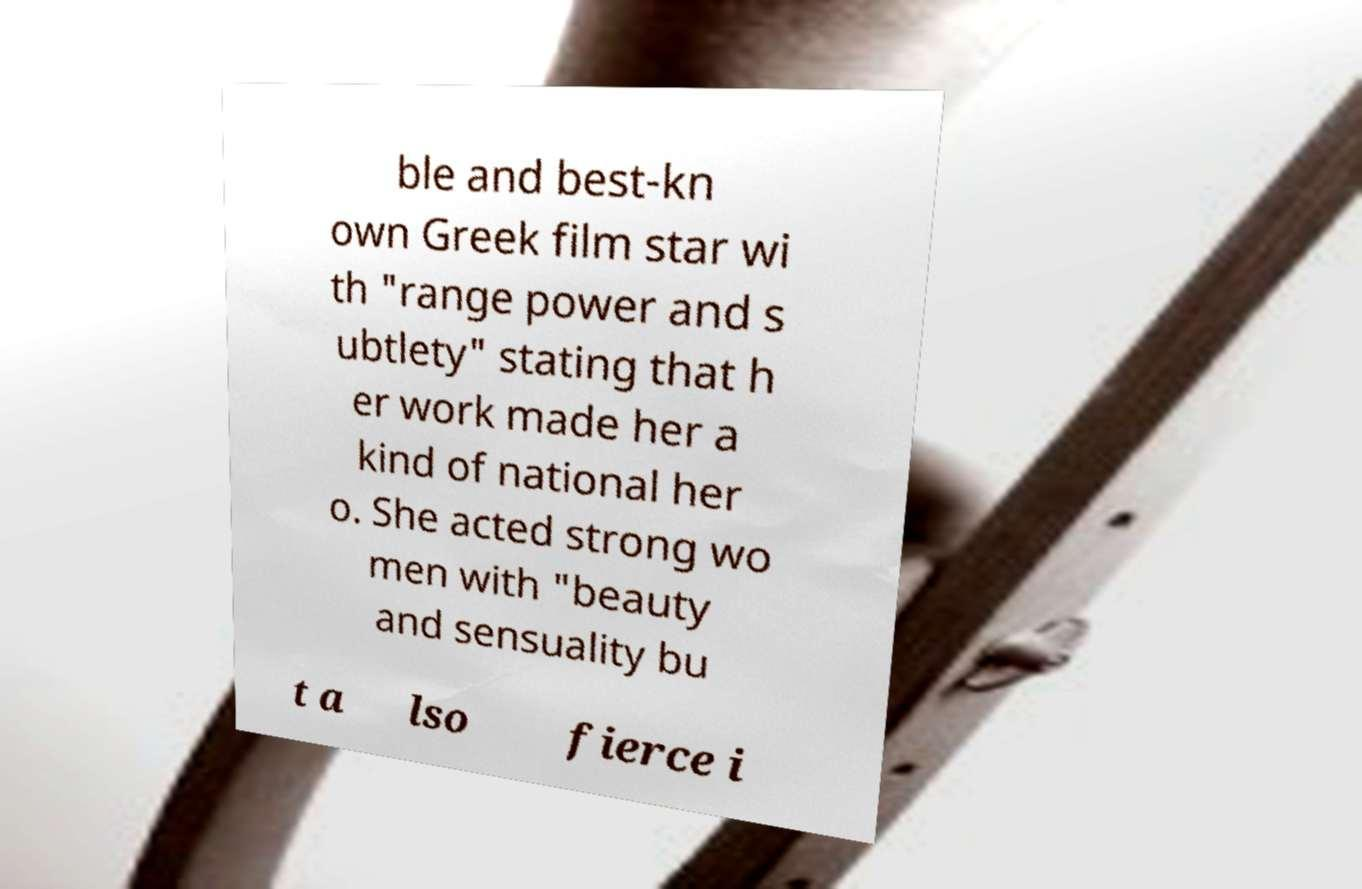There's text embedded in this image that I need extracted. Can you transcribe it verbatim? ble and best-kn own Greek film star wi th "range power and s ubtlety" stating that h er work made her a kind of national her o. She acted strong wo men with "beauty and sensuality bu t a lso fierce i 